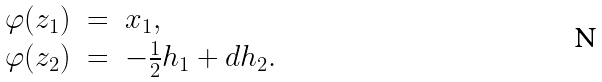Convert formula to latex. <formula><loc_0><loc_0><loc_500><loc_500>\begin{array} { l l l l l l } \varphi ( z _ { 1 } ) & = & x _ { 1 } , \\ \varphi ( z _ { 2 } ) & = & - \frac { 1 } { 2 } h _ { 1 } + d h _ { 2 } . \end{array}</formula> 